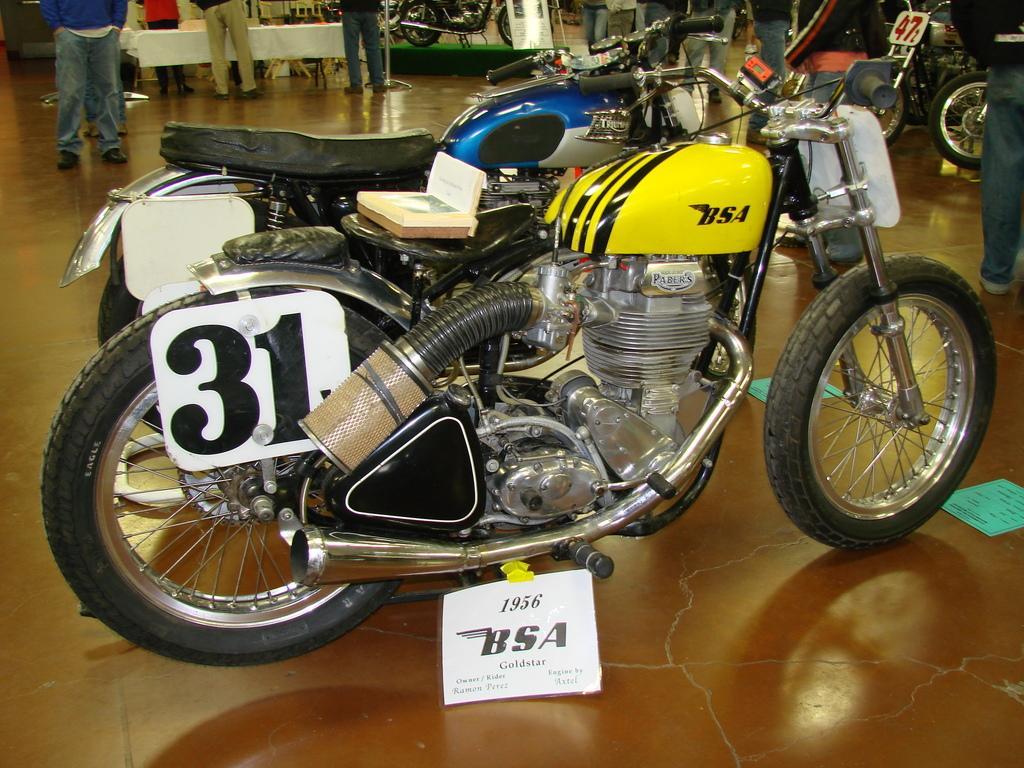Please provide a concise description of this image. In this picture there are two bikes standing on the floor, beside that i can see the posters. In the top right there is a man who is wearing jacket, jeans and shoe. He is standing near to the bikes. In the top left i can see many peoples were standing near to the table. On the table i can see the cloth, paper and other object. Beside that there is a chair. 